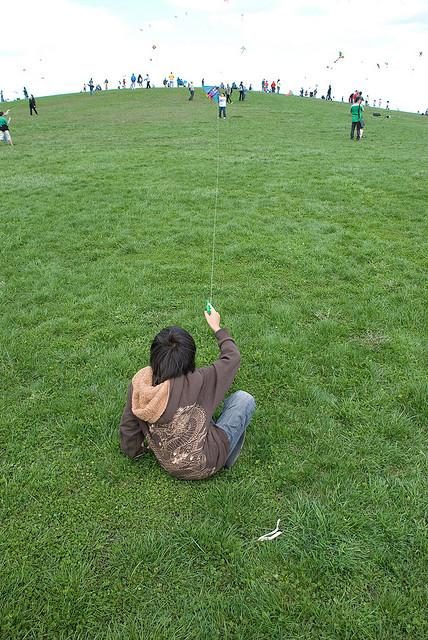What is the boy sitting in the grass doing? Please explain your reasoning. flying kite. The boy is flying the kite. 